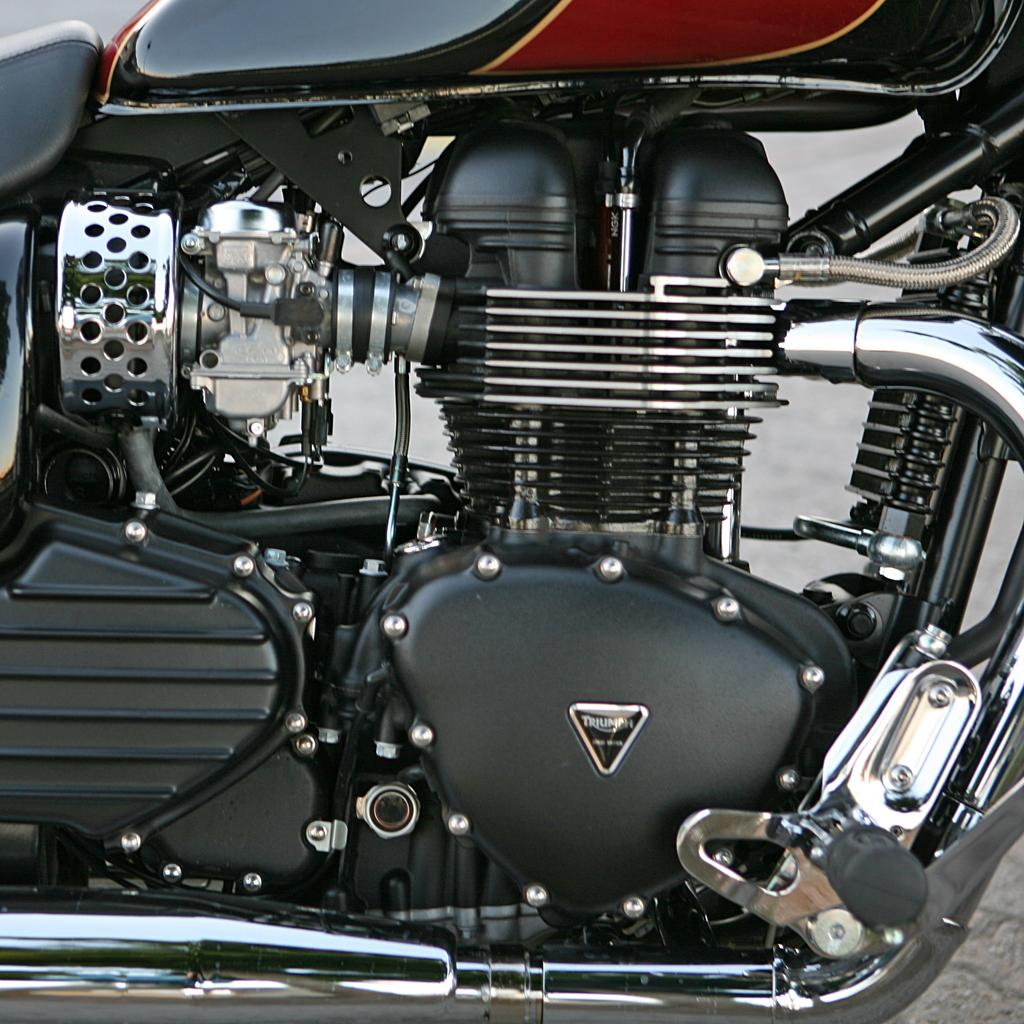What is the main subject in the image? There is a vehicle in the image. What can be seen beneath the vehicle? The ground is visible in the image. What type of pleasure does the vehicle's daughter experience in the image? There is no mention of a daughter or pleasure in the image; it only features a vehicle and the ground. 